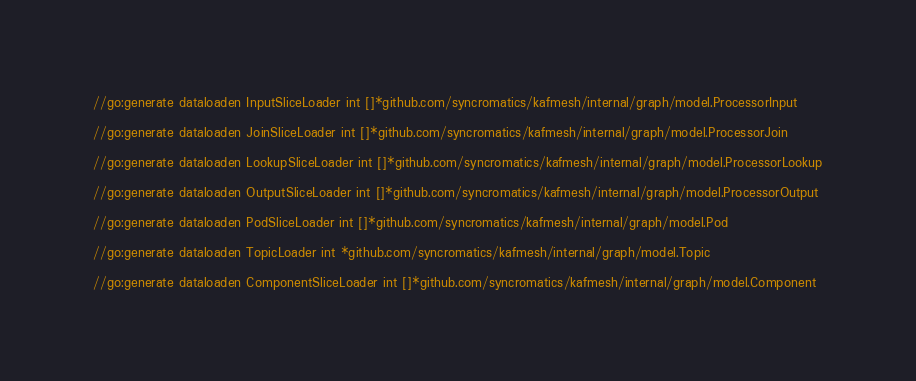<code> <loc_0><loc_0><loc_500><loc_500><_Go_>
//go:generate dataloaden InputSliceLoader int []*github.com/syncromatics/kafmesh/internal/graph/model.ProcessorInput

//go:generate dataloaden JoinSliceLoader int []*github.com/syncromatics/kafmesh/internal/graph/model.ProcessorJoin

//go:generate dataloaden LookupSliceLoader int []*github.com/syncromatics/kafmesh/internal/graph/model.ProcessorLookup

//go:generate dataloaden OutputSliceLoader int []*github.com/syncromatics/kafmesh/internal/graph/model.ProcessorOutput

//go:generate dataloaden PodSliceLoader int []*github.com/syncromatics/kafmesh/internal/graph/model.Pod

//go:generate dataloaden TopicLoader int *github.com/syncromatics/kafmesh/internal/graph/model.Topic

//go:generate dataloaden ComponentSliceLoader int []*github.com/syncromatics/kafmesh/internal/graph/model.Component
</code> 